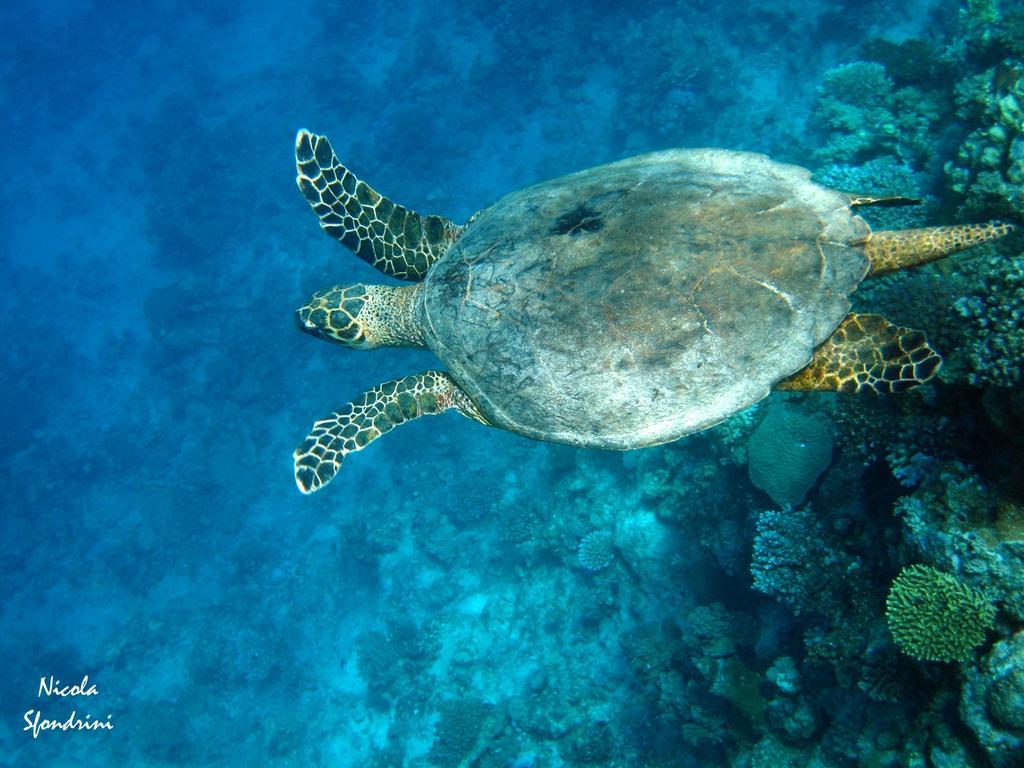Could you give a brief overview of what you see in this image? In this image there is a tortoise in the water. Under the water there are plants. There is some text on the left side of the image. 